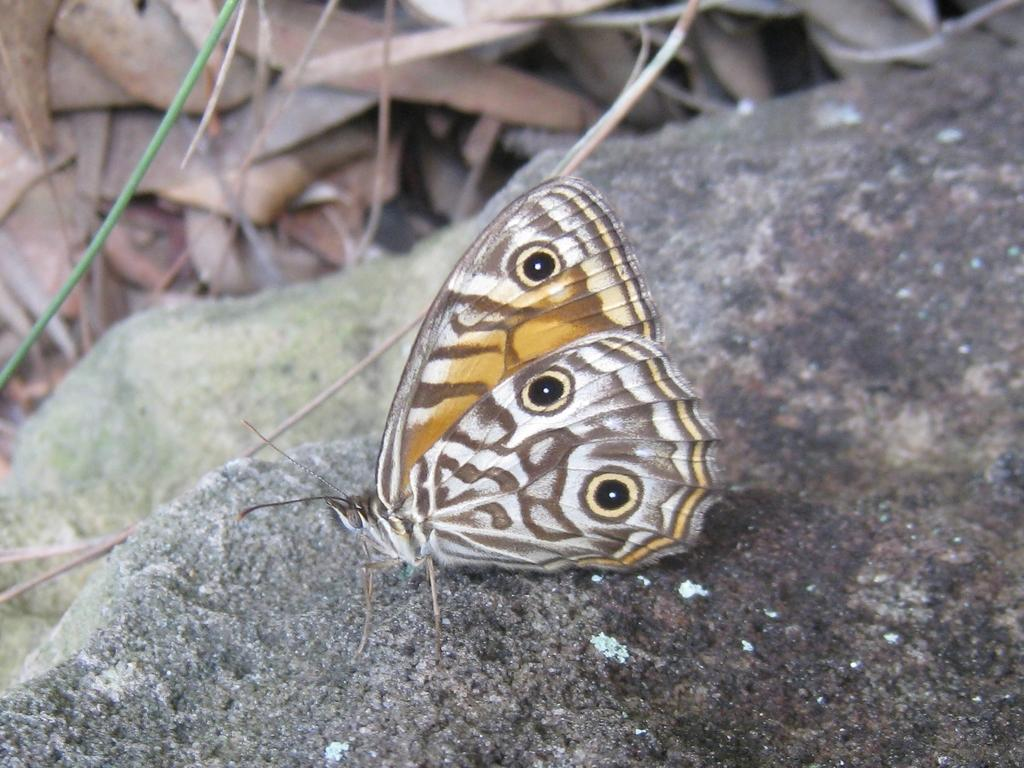What is the main subject of the image? There is a butterfly in the image. Where is the butterfly located? The butterfly is on a stone. What type of battle is taking place between the butterfly and a snake in the image? There is no snake or battle present in the image; it only features a butterfly on a stone. 